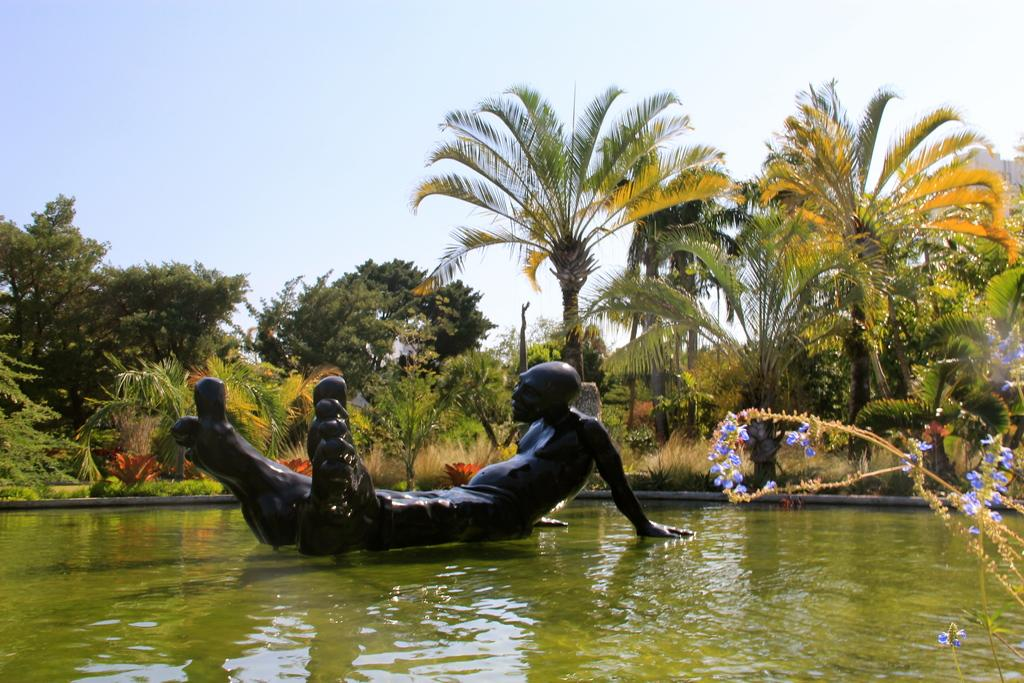What is the main feature of the image? There is a pond in the image. What can be seen inside the pond? There is a sculpture of a man in the pond. What is the color of the sculpture? The sculpture is black in color. What type of vegetation is present around the pond? There are trees around the pond. How is the zipper used in the image? There is no zipper present in the image. What is the distribution of pollution in the image? There is no mention of pollution in the image, as it features a pond with a sculpture and trees. 